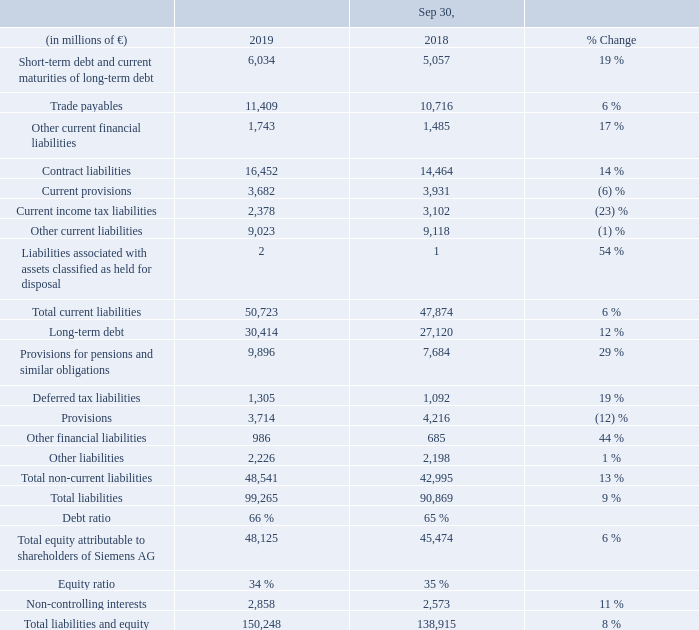A.6.1 Capital structure
The increase in short-term debt and current maturities of long-term debt was due mainly to reclassifications of long-term euro and U. S. dollar instruments totaling € 3.9 billion from longterm debt. This was partly offset by € 3.3 billion resulting from the repayment of U. S. dollar instruments.
The decrease in current income tax liabilities was driven mainly by the reversal of income tax provisions outside Germany and tax payments in the context of the carve-out activities related to Siemens Healthineers.
Long-term debt increased due primarily to the issuance of euro instruments totaling € 6.5 billion and currency translation effects for bonds issued in the U. S. dollar. This was partly offset by the above-mentioned reclassifications of euro and U. S. dollar instruments.
The increase in provisions for pensions and similar obligations was due mainly to a lower discount rate. This effect was partly offset by a positive return on plan assets, among other factors.
The main factors for the increase in total equity attributable to shareholders of Siemens AG were € 5.2 billion in net income attributable to shareholders of Siemens AG; the re-issuance of treasury shares of € 1.6 billion; and positive other comprehensive income, net of income taxes of € 0.4 billion, resulting mainly from positive currency translation effects of € 1.8 billion, partly offset by negative effects from remeasurements of defined benefit plans of € 1.1 billion. This increase was partly offset by dividend payments of € 3.1 billion (for fiscal 2018) and the repurchase of 13,532,557 treasury shares at an average cost per share of € 99.78, totaling € 1.4 billion (including incidental transaction charges).
What caused the increase in short-term debt and current maturities of long-term debt  The increase in short-term debt and current maturities of long-term debt was due mainly to reclassifications of long-term euro and u. s. dollar instruments totaling € 3.9 billion from longterm debt. this was partly offset by € 3.3 billion resulting from the repayment of u. s. dollar instruments. What caused the decrease in current income tax liability? The decrease in current income tax liabilities was driven mainly by the reversal of income tax provisions outside germany and tax payments in the context of the carve-out activities related to siemens healthineers. What caused the long-term debt to increase? Long-term debt increased due primarily to the issuance of euro instruments totaling € 6.5 billion and currency translation effects for bonds issued in the u. s. dollar. this was partly offset by the above-mentioned reclassifications of euro and u. s. dollar instruments. What were the average trade payables in 2019 and 2018?
Answer scale should be: million. (11,409 + 10,716) / 2
Answer: 11062.5. What is the increase / (decrease) in total current liabilities from 2018 to 2019?
Answer scale should be: million. 50,723 - 47,874
Answer: 2849. What is the percentage increase / (decrease) in total liabilities and equity from 2018 to 2019?
Answer scale should be: percent. 150,248 / 138,915 - 1
Answer: 8.16. 